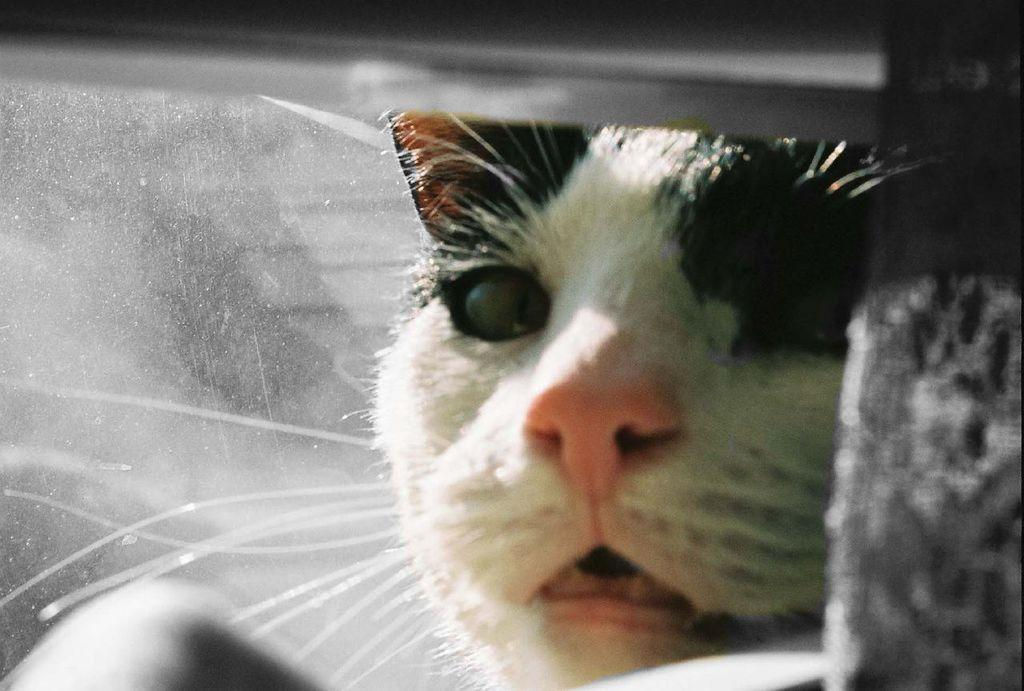What type of animal is in the image? There is a cat in the image. Can you describe the object in the image? Unfortunately, the facts provided do not give any details about the object in the image. How many horses are visible in the image? There are no horses present in the image; it features a cat and an unspecified object. What type of chin can be seen on the kitten in the image? There is no kitten present in the image, only a cat. 